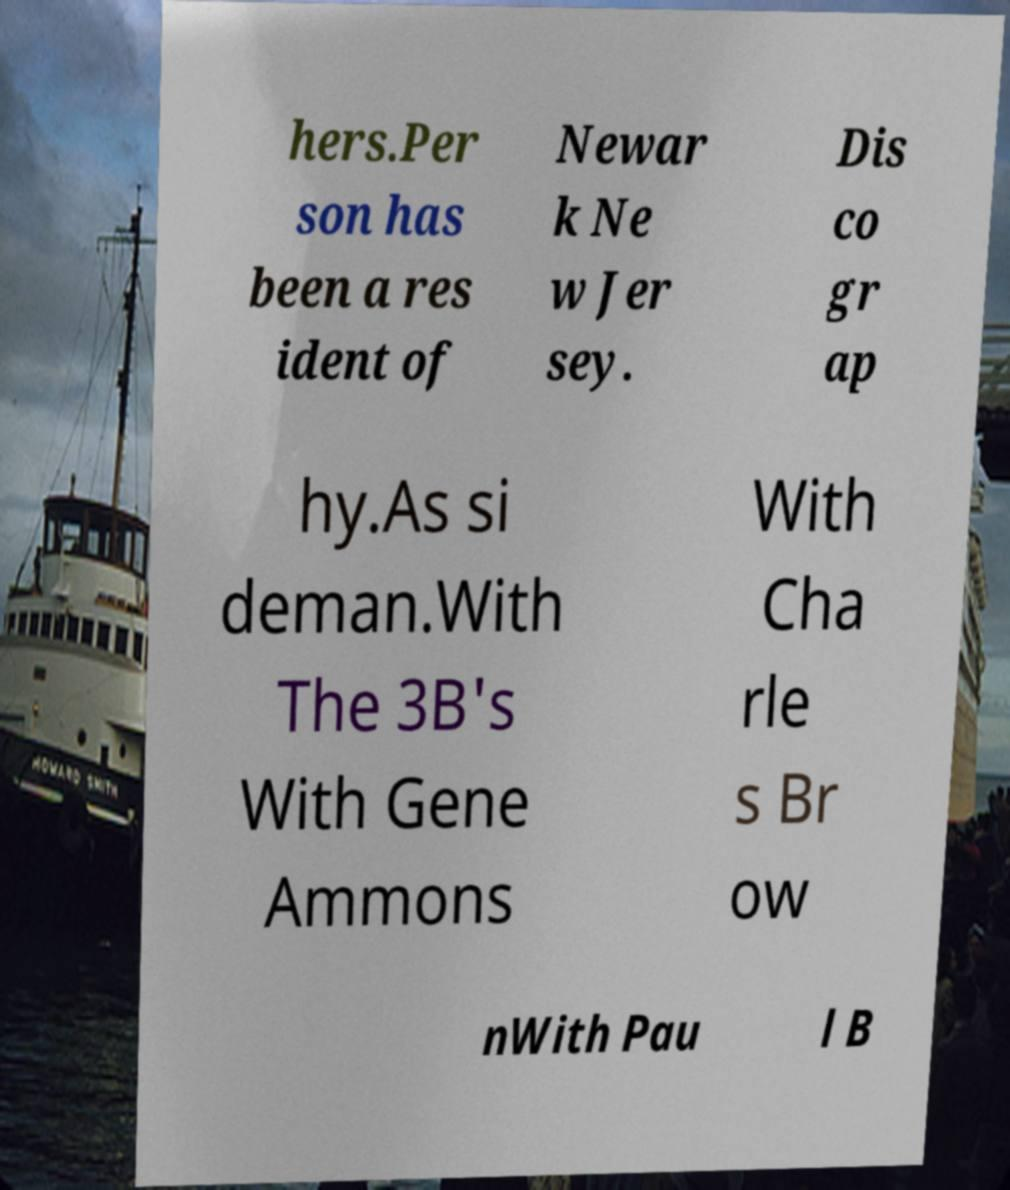Could you extract and type out the text from this image? hers.Per son has been a res ident of Newar k Ne w Jer sey. Dis co gr ap hy.As si deman.With The 3B's With Gene Ammons With Cha rle s Br ow nWith Pau l B 